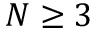Convert formula to latex. <formula><loc_0><loc_0><loc_500><loc_500>N \geq 3</formula> 